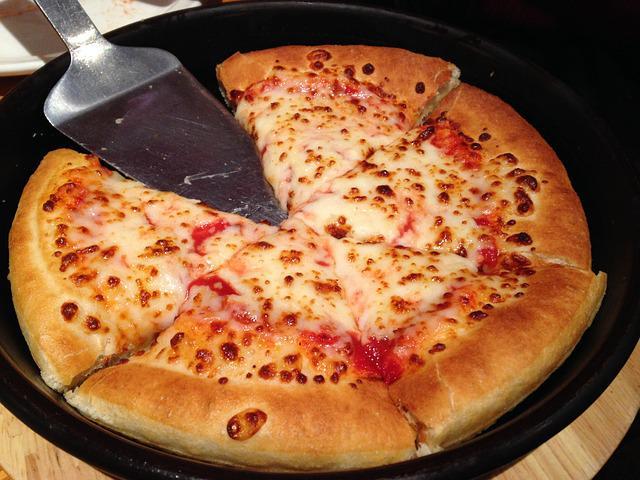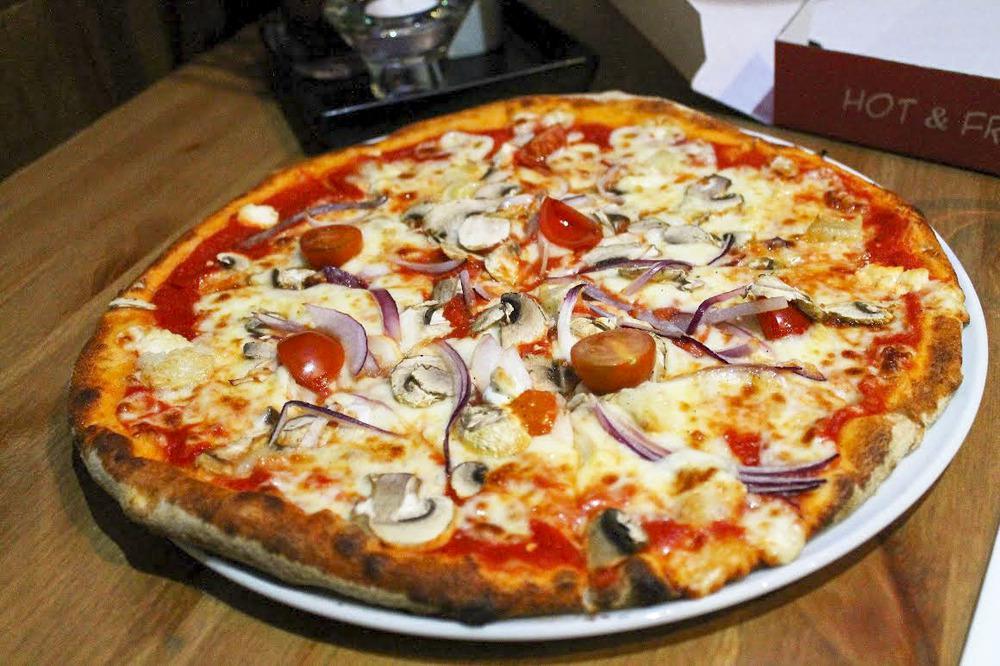The first image is the image on the left, the second image is the image on the right. Given the left and right images, does the statement "Each image shows a full round pizza." hold true? Answer yes or no. No. The first image is the image on the left, the second image is the image on the right. For the images displayed, is the sentence "One of the pizzas has no other toppings but cheese." factually correct? Answer yes or no. Yes. 